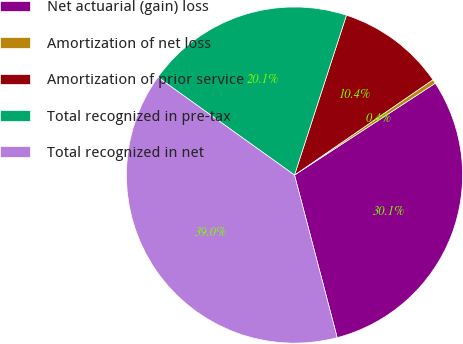Convert chart to OTSL. <chart><loc_0><loc_0><loc_500><loc_500><pie_chart><fcel>Net actuarial (gain) loss<fcel>Amortization of net loss<fcel>Amortization of prior service<fcel>Total recognized in pre-tax<fcel>Total recognized in net<nl><fcel>30.11%<fcel>0.4%<fcel>10.4%<fcel>20.11%<fcel>38.98%<nl></chart> 